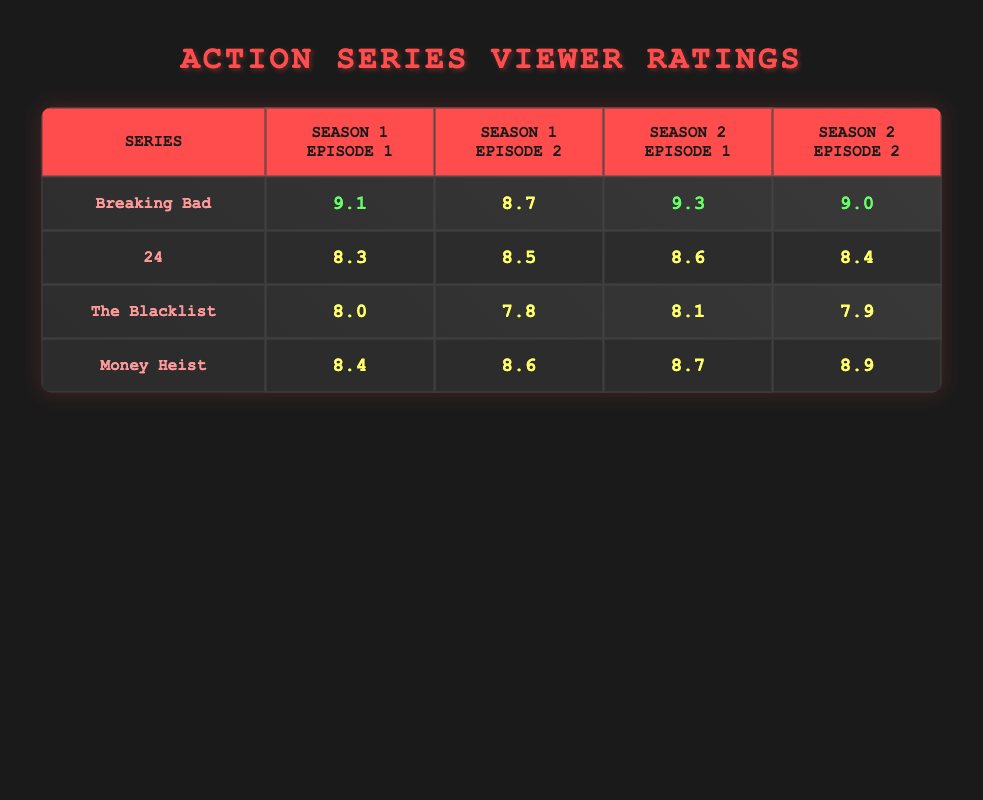What is the highest rating for any episode in "Breaking Bad"? The highest rating for an episode in "Breaking Bad" is 9.3, which is from Season 2, Episode 1.
Answer: 9.3 Which series has the lowest-rated episode in Season 1? In Season 1, "The Blacklist" has the lowest-rated episode, which is Episode 2 with a rating of 7.8.
Answer: 7.8 What is the average rating for both episodes of "24" in Season 1? To find the average rating for "24" Season 1, sum the ratings of Episode 1 (8.3) and Episode 2 (8.5) which is 8.3 + 8.5 = 16.8. Divide by 2 to get the average: 16.8 / 2 = 8.4.
Answer: 8.4 Did "Money Heist" receive a higher rating in Season 2 compared to Season 1? Yes, the ratings for "Money Heist" in Season 2 are 8.7 and 8.9 for Episodes 1 and 2, respectively, which are higher than the Season 1 ratings of 8.4 and 8.6.
Answer: Yes What is the difference in ratings between the highest and lowest episode in "The Blacklist"? The highest rating in "The Blacklist" is 8.1 (Season 2, Episode 1) and the lowest is 7.8 (Season 1, Episode 2). The difference is 8.1 - 7.8 = 0.3.
Answer: 0.3 